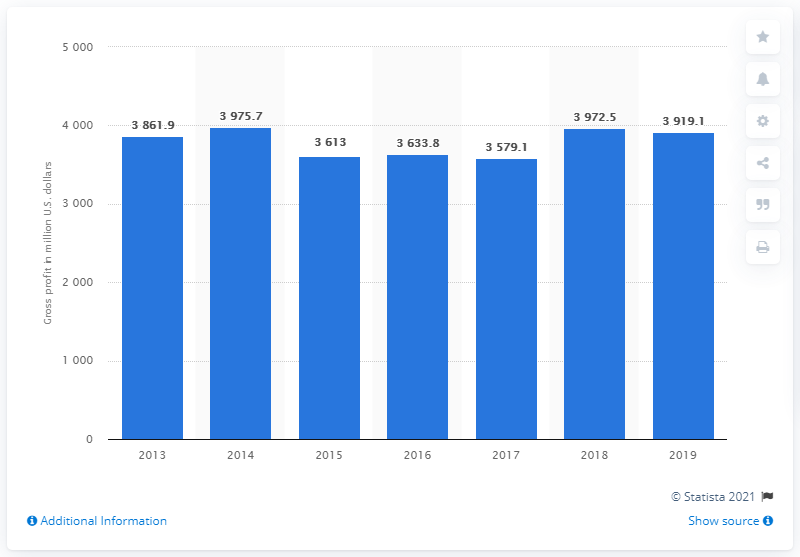Highlight a few significant elements in this photo. Herbalife's gross profit in 2019 was 3919.1. 